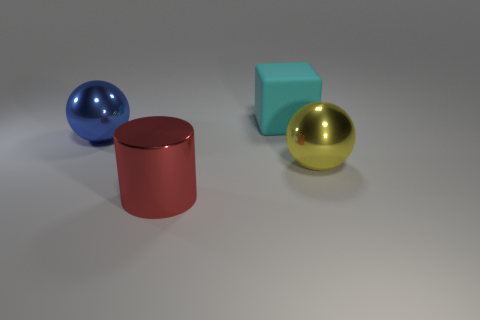Add 1 big gray rubber spheres. How many objects exist? 5 Subtract all cylinders. How many objects are left? 3 Subtract 0 purple spheres. How many objects are left? 4 Subtract all objects. Subtract all small red blocks. How many objects are left? 0 Add 1 big balls. How many big balls are left? 3 Add 2 large matte things. How many large matte things exist? 3 